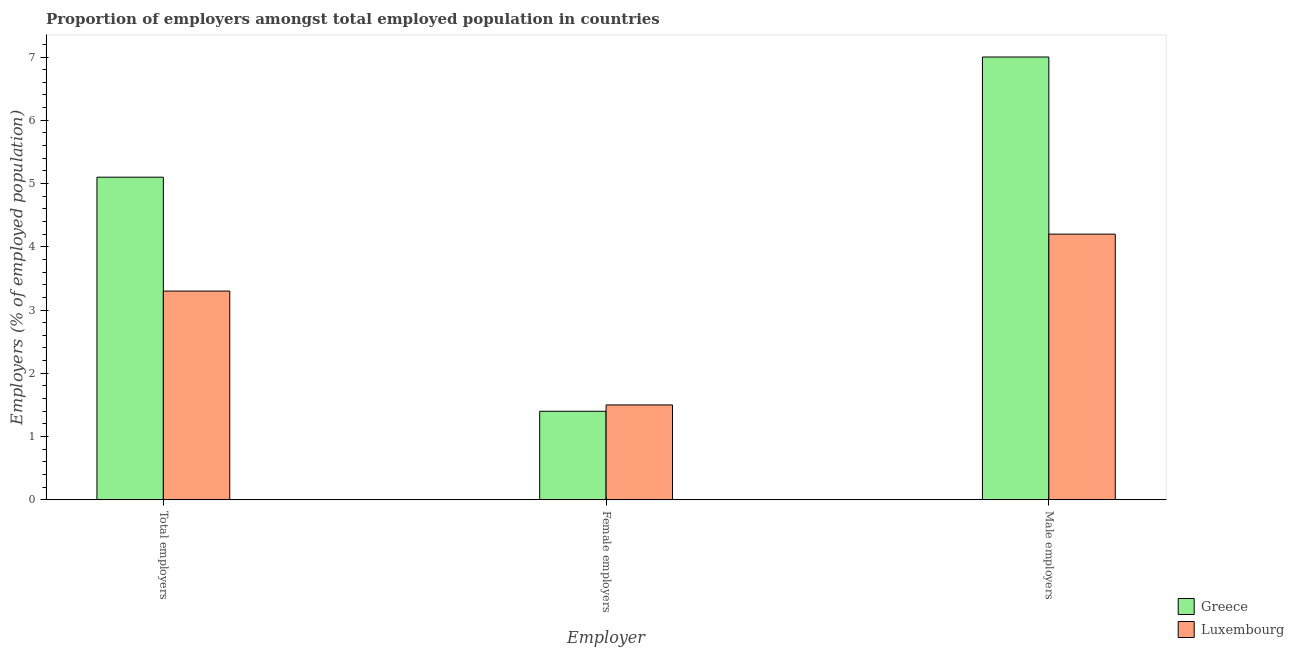How many different coloured bars are there?
Provide a succinct answer. 2. Are the number of bars per tick equal to the number of legend labels?
Offer a terse response. Yes. Are the number of bars on each tick of the X-axis equal?
Your response must be concise. Yes. How many bars are there on the 3rd tick from the left?
Provide a succinct answer. 2. What is the label of the 3rd group of bars from the left?
Provide a short and direct response. Male employers. What is the percentage of female employers in Greece?
Your answer should be very brief. 1.4. Across all countries, what is the maximum percentage of female employers?
Make the answer very short. 1.5. Across all countries, what is the minimum percentage of total employers?
Your response must be concise. 3.3. In which country was the percentage of male employers minimum?
Offer a very short reply. Luxembourg. What is the total percentage of total employers in the graph?
Offer a very short reply. 8.4. What is the difference between the percentage of male employers in Greece and that in Luxembourg?
Make the answer very short. 2.8. What is the difference between the percentage of male employers in Luxembourg and the percentage of total employers in Greece?
Provide a short and direct response. -0.9. What is the average percentage of total employers per country?
Your answer should be compact. 4.2. What is the difference between the percentage of total employers and percentage of male employers in Luxembourg?
Provide a short and direct response. -0.9. In how many countries, is the percentage of female employers greater than 2.2 %?
Your answer should be very brief. 0. What is the ratio of the percentage of male employers in Luxembourg to that in Greece?
Offer a terse response. 0.6. Is the percentage of male employers in Luxembourg less than that in Greece?
Give a very brief answer. Yes. What is the difference between the highest and the second highest percentage of total employers?
Your answer should be very brief. 1.8. What is the difference between the highest and the lowest percentage of male employers?
Provide a short and direct response. 2.8. In how many countries, is the percentage of female employers greater than the average percentage of female employers taken over all countries?
Keep it short and to the point. 1. What does the 1st bar from the left in Female employers represents?
Ensure brevity in your answer.  Greece. What does the 1st bar from the right in Female employers represents?
Your answer should be very brief. Luxembourg. Is it the case that in every country, the sum of the percentage of total employers and percentage of female employers is greater than the percentage of male employers?
Provide a short and direct response. No. Are the values on the major ticks of Y-axis written in scientific E-notation?
Keep it short and to the point. No. Does the graph contain any zero values?
Give a very brief answer. No. Where does the legend appear in the graph?
Offer a very short reply. Bottom right. How are the legend labels stacked?
Offer a very short reply. Vertical. What is the title of the graph?
Offer a very short reply. Proportion of employers amongst total employed population in countries. Does "Tonga" appear as one of the legend labels in the graph?
Offer a terse response. No. What is the label or title of the X-axis?
Your answer should be compact. Employer. What is the label or title of the Y-axis?
Provide a succinct answer. Employers (% of employed population). What is the Employers (% of employed population) in Greece in Total employers?
Provide a short and direct response. 5.1. What is the Employers (% of employed population) in Luxembourg in Total employers?
Your answer should be compact. 3.3. What is the Employers (% of employed population) of Greece in Female employers?
Your answer should be compact. 1.4. What is the Employers (% of employed population) in Luxembourg in Female employers?
Keep it short and to the point. 1.5. What is the Employers (% of employed population) in Luxembourg in Male employers?
Provide a succinct answer. 4.2. Across all Employer, what is the maximum Employers (% of employed population) in Luxembourg?
Provide a short and direct response. 4.2. Across all Employer, what is the minimum Employers (% of employed population) in Greece?
Offer a terse response. 1.4. Across all Employer, what is the minimum Employers (% of employed population) in Luxembourg?
Provide a short and direct response. 1.5. What is the difference between the Employers (% of employed population) of Greece in Total employers and that in Male employers?
Give a very brief answer. -1.9. What is the difference between the Employers (% of employed population) of Greece in Female employers and that in Male employers?
Your response must be concise. -5.6. What is the difference between the Employers (% of employed population) of Greece in Total employers and the Employers (% of employed population) of Luxembourg in Female employers?
Your answer should be compact. 3.6. What is the average Employers (% of employed population) in Greece per Employer?
Offer a very short reply. 4.5. What is the average Employers (% of employed population) of Luxembourg per Employer?
Ensure brevity in your answer.  3. What is the difference between the Employers (% of employed population) in Greece and Employers (% of employed population) in Luxembourg in Total employers?
Your answer should be compact. 1.8. What is the difference between the Employers (% of employed population) of Greece and Employers (% of employed population) of Luxembourg in Female employers?
Provide a short and direct response. -0.1. What is the ratio of the Employers (% of employed population) in Greece in Total employers to that in Female employers?
Give a very brief answer. 3.64. What is the ratio of the Employers (% of employed population) of Greece in Total employers to that in Male employers?
Your answer should be compact. 0.73. What is the ratio of the Employers (% of employed population) in Luxembourg in Total employers to that in Male employers?
Your answer should be compact. 0.79. What is the ratio of the Employers (% of employed population) of Greece in Female employers to that in Male employers?
Provide a short and direct response. 0.2. What is the ratio of the Employers (% of employed population) of Luxembourg in Female employers to that in Male employers?
Ensure brevity in your answer.  0.36. What is the difference between the highest and the second highest Employers (% of employed population) in Luxembourg?
Ensure brevity in your answer.  0.9. 